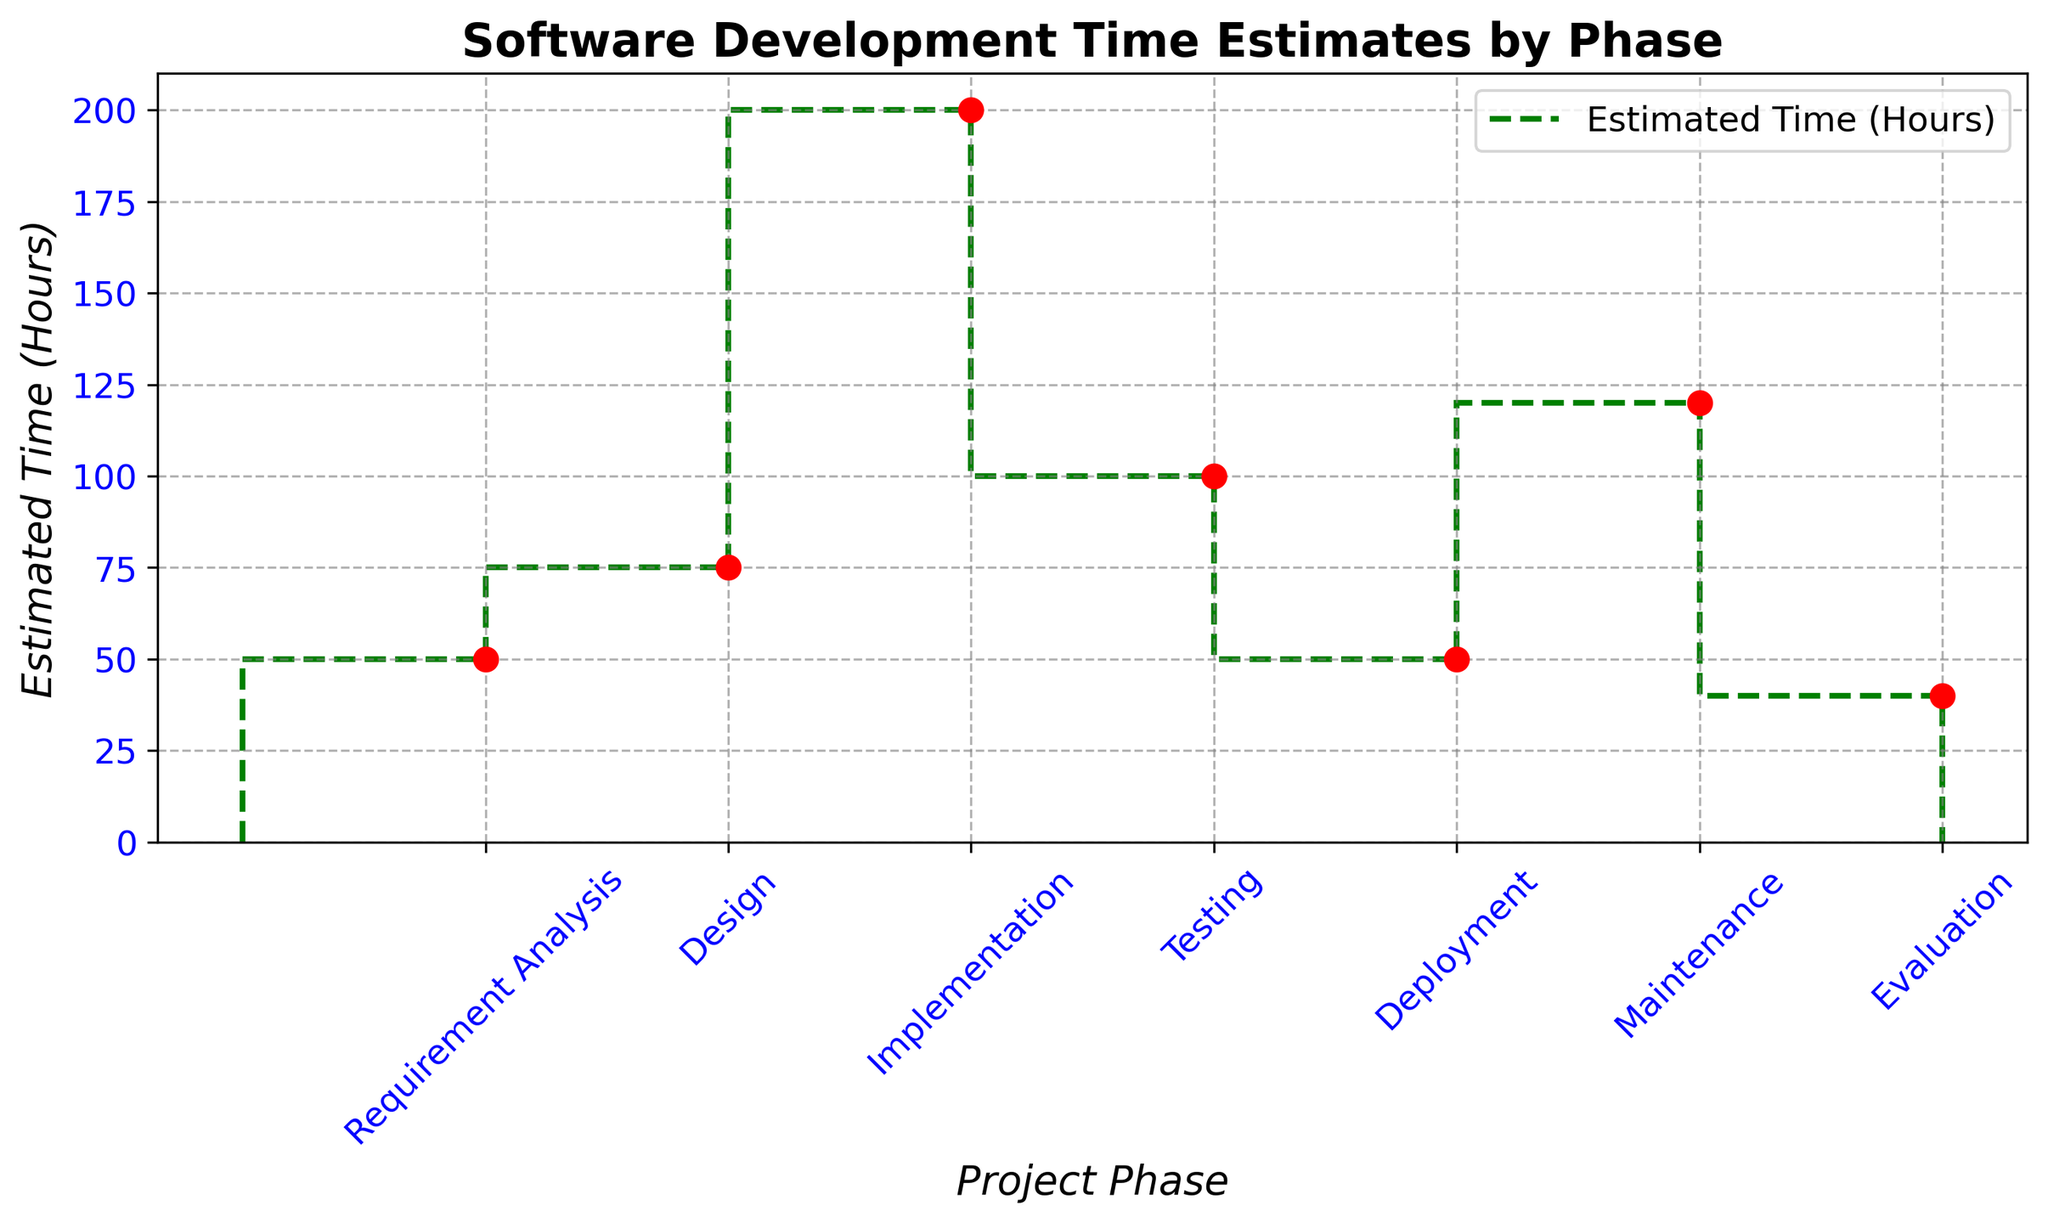What is the phase with the highest estimated time? The figure shows the highest step on the y-axis at 200 hours, corresponding to the 'Implementation' phase.
Answer: Implementation Which phase has an estimated time equal to Requirement Analysis? By checking the y-axis values, both 'Requirement Analysis' and 'Deployment' have an estimated time of 50 hours.
Answer: Deployment What is the combined estimated time for the Design and Testing phases? The estimated time for 'Design' is 75 hours and for 'Testing' is 100 hours. Adding them: 75 + 100 = 175 hours.
Answer: 175 Which phases have the lowest estimated time? The figure shows the lowest estimated time as 40 hours for the 'Evaluation' phase.
Answer: Evaluation How does the estimated time for Maintenance compare with Requirement Analysis and Deployment combined? Maintenance has 120 hours; Requirement Analysis and Deployment are both 50 hours. Summing them: 50 + 50 = 100 hours. Since 120 > 100, Maintenance has a higher estimated time.
Answer: Maintenance What is the average estimated time for all phases? Sum all the times (50 + 75 + 200 + 100 + 50 + 120 + 40 = 635). There are 7 phases. Average = 635/7 ≈ 90.71 hours.
Answer: 90.71 What is the difference in estimated time between Implementation and Design phases? The figure provides 200 hours for 'Implementation' and 75 hours for 'Design'. The difference is 200 - 75 = 125 hours.
Answer: 125 Which phase follows the Testing phase in estimated time? The figure shows the 'Deployment' phase following 'Testing', with an estimated time of 50 hours.
Answer: Deployment What is the total estimated time from Requirement Analysis to Deployment phases? The cumulative time includes Requirement Analysis (50), Design (75), Implementation (200), Testing (100), and Deployment (50). Total = 50 + 75 + 200 + 100 + 50 = 475 hours.
Answer: 475 Comparing Testing and Evaluation, which phase takes more time and by how much? 'Testing' takes 100 hours while 'Evaluation' takes 40 hours. The difference is 100 - 40 = 60 hours.
Answer: Testing, 60 